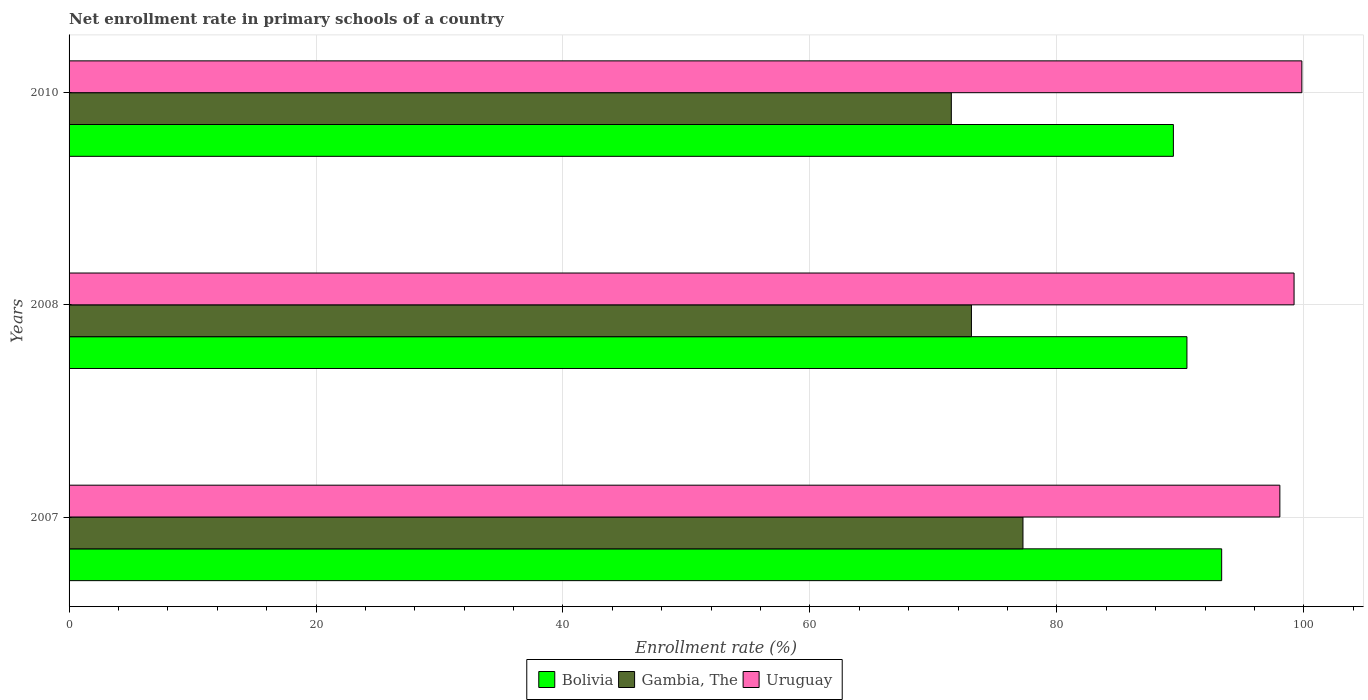How many bars are there on the 1st tick from the bottom?
Ensure brevity in your answer.  3. In how many cases, is the number of bars for a given year not equal to the number of legend labels?
Your answer should be compact. 0. What is the enrollment rate in primary schools in Uruguay in 2007?
Make the answer very short. 98.06. Across all years, what is the maximum enrollment rate in primary schools in Gambia, The?
Provide a succinct answer. 77.25. Across all years, what is the minimum enrollment rate in primary schools in Bolivia?
Give a very brief answer. 89.43. In which year was the enrollment rate in primary schools in Gambia, The minimum?
Your response must be concise. 2010. What is the total enrollment rate in primary schools in Uruguay in the graph?
Your answer should be compact. 297.1. What is the difference between the enrollment rate in primary schools in Uruguay in 2007 and that in 2008?
Your answer should be compact. -1.15. What is the difference between the enrollment rate in primary schools in Gambia, The in 2010 and the enrollment rate in primary schools in Bolivia in 2007?
Your response must be concise. -21.89. What is the average enrollment rate in primary schools in Gambia, The per year?
Provide a short and direct response. 73.93. In the year 2008, what is the difference between the enrollment rate in primary schools in Uruguay and enrollment rate in primary schools in Bolivia?
Offer a terse response. 8.68. What is the ratio of the enrollment rate in primary schools in Bolivia in 2007 to that in 2010?
Give a very brief answer. 1.04. Is the enrollment rate in primary schools in Gambia, The in 2008 less than that in 2010?
Ensure brevity in your answer.  No. What is the difference between the highest and the second highest enrollment rate in primary schools in Uruguay?
Ensure brevity in your answer.  0.63. What is the difference between the highest and the lowest enrollment rate in primary schools in Bolivia?
Give a very brief answer. 3.91. In how many years, is the enrollment rate in primary schools in Bolivia greater than the average enrollment rate in primary schools in Bolivia taken over all years?
Give a very brief answer. 1. Is the sum of the enrollment rate in primary schools in Gambia, The in 2008 and 2010 greater than the maximum enrollment rate in primary schools in Uruguay across all years?
Provide a succinct answer. Yes. What does the 2nd bar from the top in 2008 represents?
Keep it short and to the point. Gambia, The. What does the 2nd bar from the bottom in 2010 represents?
Your answer should be very brief. Gambia, The. What is the difference between two consecutive major ticks on the X-axis?
Provide a short and direct response. 20. Where does the legend appear in the graph?
Your answer should be compact. Bottom center. How many legend labels are there?
Offer a very short reply. 3. How are the legend labels stacked?
Your response must be concise. Horizontal. What is the title of the graph?
Your response must be concise. Net enrollment rate in primary schools of a country. Does "Ecuador" appear as one of the legend labels in the graph?
Ensure brevity in your answer.  No. What is the label or title of the X-axis?
Ensure brevity in your answer.  Enrollment rate (%). What is the Enrollment rate (%) of Bolivia in 2007?
Your response must be concise. 93.34. What is the Enrollment rate (%) of Gambia, The in 2007?
Make the answer very short. 77.25. What is the Enrollment rate (%) of Uruguay in 2007?
Give a very brief answer. 98.06. What is the Enrollment rate (%) in Bolivia in 2008?
Give a very brief answer. 90.53. What is the Enrollment rate (%) in Gambia, The in 2008?
Offer a very short reply. 73.08. What is the Enrollment rate (%) in Uruguay in 2008?
Provide a short and direct response. 99.21. What is the Enrollment rate (%) of Bolivia in 2010?
Ensure brevity in your answer.  89.43. What is the Enrollment rate (%) in Gambia, The in 2010?
Offer a very short reply. 71.45. What is the Enrollment rate (%) of Uruguay in 2010?
Provide a short and direct response. 99.84. Across all years, what is the maximum Enrollment rate (%) in Bolivia?
Give a very brief answer. 93.34. Across all years, what is the maximum Enrollment rate (%) of Gambia, The?
Offer a very short reply. 77.25. Across all years, what is the maximum Enrollment rate (%) of Uruguay?
Provide a short and direct response. 99.84. Across all years, what is the minimum Enrollment rate (%) of Bolivia?
Provide a succinct answer. 89.43. Across all years, what is the minimum Enrollment rate (%) in Gambia, The?
Provide a succinct answer. 71.45. Across all years, what is the minimum Enrollment rate (%) of Uruguay?
Keep it short and to the point. 98.06. What is the total Enrollment rate (%) in Bolivia in the graph?
Your response must be concise. 273.31. What is the total Enrollment rate (%) in Gambia, The in the graph?
Ensure brevity in your answer.  221.78. What is the total Enrollment rate (%) of Uruguay in the graph?
Offer a terse response. 297.1. What is the difference between the Enrollment rate (%) of Bolivia in 2007 and that in 2008?
Provide a succinct answer. 2.81. What is the difference between the Enrollment rate (%) of Gambia, The in 2007 and that in 2008?
Ensure brevity in your answer.  4.17. What is the difference between the Enrollment rate (%) of Uruguay in 2007 and that in 2008?
Provide a succinct answer. -1.15. What is the difference between the Enrollment rate (%) in Bolivia in 2007 and that in 2010?
Keep it short and to the point. 3.91. What is the difference between the Enrollment rate (%) in Gambia, The in 2007 and that in 2010?
Make the answer very short. 5.8. What is the difference between the Enrollment rate (%) of Uruguay in 2007 and that in 2010?
Offer a terse response. -1.78. What is the difference between the Enrollment rate (%) of Bolivia in 2008 and that in 2010?
Provide a succinct answer. 1.1. What is the difference between the Enrollment rate (%) of Gambia, The in 2008 and that in 2010?
Make the answer very short. 1.63. What is the difference between the Enrollment rate (%) in Uruguay in 2008 and that in 2010?
Your response must be concise. -0.63. What is the difference between the Enrollment rate (%) of Bolivia in 2007 and the Enrollment rate (%) of Gambia, The in 2008?
Your answer should be compact. 20.27. What is the difference between the Enrollment rate (%) of Bolivia in 2007 and the Enrollment rate (%) of Uruguay in 2008?
Keep it short and to the point. -5.86. What is the difference between the Enrollment rate (%) in Gambia, The in 2007 and the Enrollment rate (%) in Uruguay in 2008?
Your response must be concise. -21.95. What is the difference between the Enrollment rate (%) in Bolivia in 2007 and the Enrollment rate (%) in Gambia, The in 2010?
Offer a very short reply. 21.89. What is the difference between the Enrollment rate (%) of Bolivia in 2007 and the Enrollment rate (%) of Uruguay in 2010?
Your answer should be compact. -6.49. What is the difference between the Enrollment rate (%) in Gambia, The in 2007 and the Enrollment rate (%) in Uruguay in 2010?
Provide a succinct answer. -22.59. What is the difference between the Enrollment rate (%) in Bolivia in 2008 and the Enrollment rate (%) in Gambia, The in 2010?
Your answer should be compact. 19.08. What is the difference between the Enrollment rate (%) in Bolivia in 2008 and the Enrollment rate (%) in Uruguay in 2010?
Make the answer very short. -9.31. What is the difference between the Enrollment rate (%) in Gambia, The in 2008 and the Enrollment rate (%) in Uruguay in 2010?
Your answer should be compact. -26.76. What is the average Enrollment rate (%) in Bolivia per year?
Your response must be concise. 91.1. What is the average Enrollment rate (%) of Gambia, The per year?
Ensure brevity in your answer.  73.93. What is the average Enrollment rate (%) of Uruguay per year?
Make the answer very short. 99.03. In the year 2007, what is the difference between the Enrollment rate (%) of Bolivia and Enrollment rate (%) of Gambia, The?
Provide a short and direct response. 16.09. In the year 2007, what is the difference between the Enrollment rate (%) of Bolivia and Enrollment rate (%) of Uruguay?
Your answer should be very brief. -4.71. In the year 2007, what is the difference between the Enrollment rate (%) in Gambia, The and Enrollment rate (%) in Uruguay?
Provide a short and direct response. -20.8. In the year 2008, what is the difference between the Enrollment rate (%) of Bolivia and Enrollment rate (%) of Gambia, The?
Offer a terse response. 17.45. In the year 2008, what is the difference between the Enrollment rate (%) of Bolivia and Enrollment rate (%) of Uruguay?
Make the answer very short. -8.68. In the year 2008, what is the difference between the Enrollment rate (%) in Gambia, The and Enrollment rate (%) in Uruguay?
Give a very brief answer. -26.13. In the year 2010, what is the difference between the Enrollment rate (%) in Bolivia and Enrollment rate (%) in Gambia, The?
Provide a succinct answer. 17.98. In the year 2010, what is the difference between the Enrollment rate (%) of Bolivia and Enrollment rate (%) of Uruguay?
Ensure brevity in your answer.  -10.4. In the year 2010, what is the difference between the Enrollment rate (%) in Gambia, The and Enrollment rate (%) in Uruguay?
Offer a very short reply. -28.39. What is the ratio of the Enrollment rate (%) in Bolivia in 2007 to that in 2008?
Your answer should be very brief. 1.03. What is the ratio of the Enrollment rate (%) in Gambia, The in 2007 to that in 2008?
Ensure brevity in your answer.  1.06. What is the ratio of the Enrollment rate (%) of Uruguay in 2007 to that in 2008?
Ensure brevity in your answer.  0.99. What is the ratio of the Enrollment rate (%) in Bolivia in 2007 to that in 2010?
Offer a terse response. 1.04. What is the ratio of the Enrollment rate (%) in Gambia, The in 2007 to that in 2010?
Your answer should be very brief. 1.08. What is the ratio of the Enrollment rate (%) of Uruguay in 2007 to that in 2010?
Provide a short and direct response. 0.98. What is the ratio of the Enrollment rate (%) of Bolivia in 2008 to that in 2010?
Make the answer very short. 1.01. What is the ratio of the Enrollment rate (%) of Gambia, The in 2008 to that in 2010?
Provide a short and direct response. 1.02. What is the ratio of the Enrollment rate (%) of Uruguay in 2008 to that in 2010?
Make the answer very short. 0.99. What is the difference between the highest and the second highest Enrollment rate (%) in Bolivia?
Keep it short and to the point. 2.81. What is the difference between the highest and the second highest Enrollment rate (%) of Gambia, The?
Your answer should be compact. 4.17. What is the difference between the highest and the second highest Enrollment rate (%) in Uruguay?
Provide a succinct answer. 0.63. What is the difference between the highest and the lowest Enrollment rate (%) in Bolivia?
Give a very brief answer. 3.91. What is the difference between the highest and the lowest Enrollment rate (%) in Gambia, The?
Your response must be concise. 5.8. What is the difference between the highest and the lowest Enrollment rate (%) in Uruguay?
Provide a short and direct response. 1.78. 